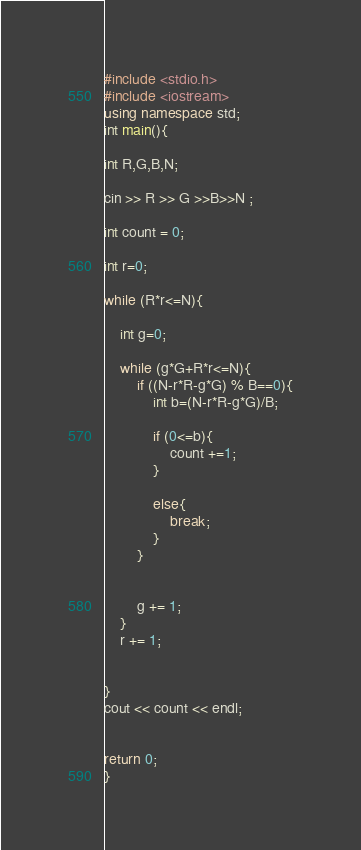Convert code to text. <code><loc_0><loc_0><loc_500><loc_500><_C++_>#include <stdio.h>
#include <iostream>
using namespace std;
int main(){

int R,G,B,N;

cin >> R >> G >>B>>N ;

int count = 0;

int r=0;

while (R*r<=N){

    int g=0;

    while (g*G+R*r<=N){
        if ((N-r*R-g*G) % B==0){
            int b=(N-r*R-g*G)/B;

            if (0<=b){
                count +=1;
            }
                
            else{
                break;
            }
        }

            
        g += 1;
    }
    r += 1;


}
cout << count << endl;   


return 0;
}
</code> 